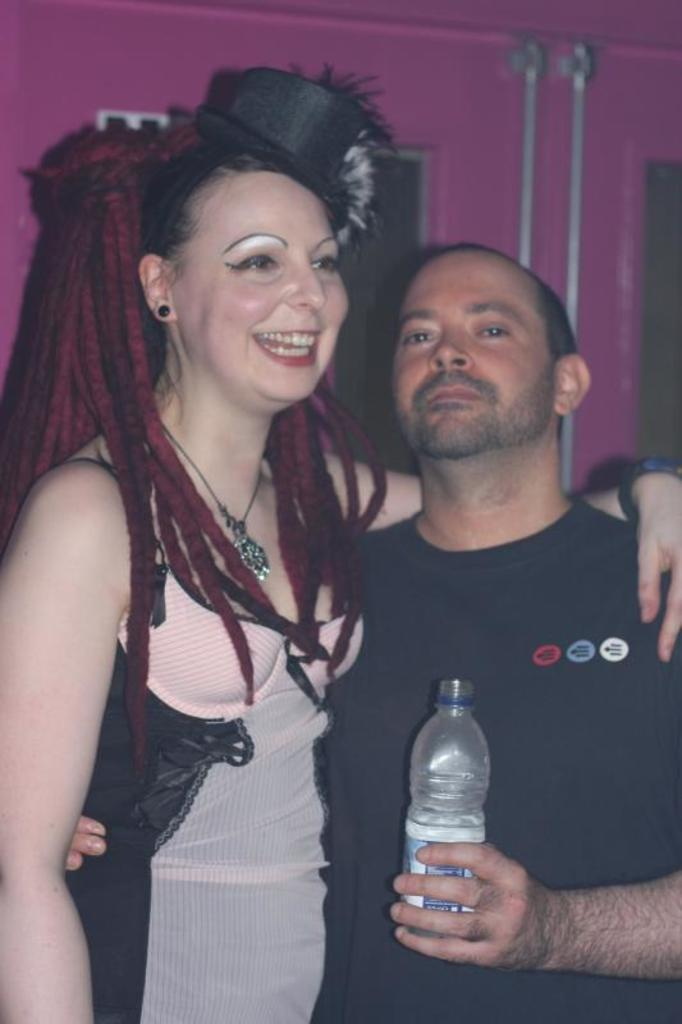How many people are standing in the image? There are two people standing in the image, a man and a woman. What is the man holding in his hand in the image? The man is holding a water bottle in his hand in the image. What type of bed can be seen in the image? There is no bed present in the image. What is the effect of the water bottle on the woman in the image? There is no indication in the image that the water bottle has any effect on the woman. 